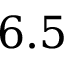<formula> <loc_0><loc_0><loc_500><loc_500>6 . 5</formula> 